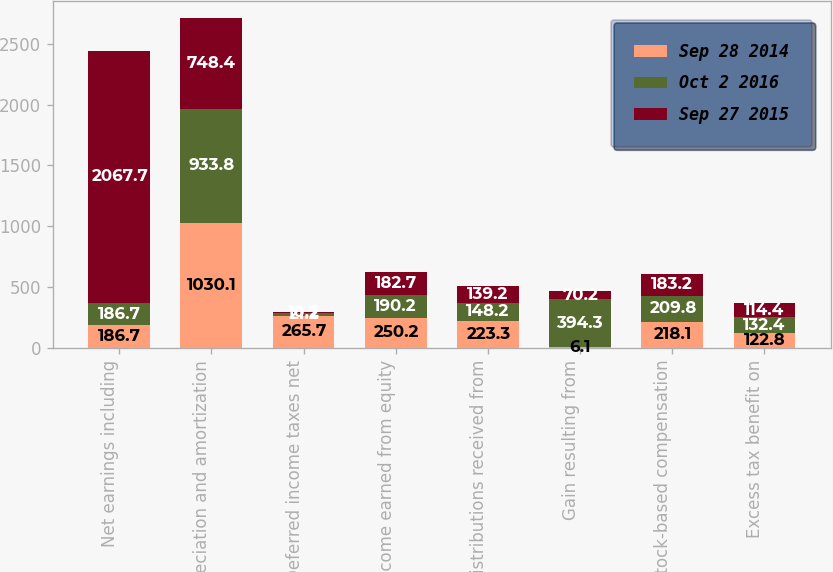<chart> <loc_0><loc_0><loc_500><loc_500><stacked_bar_chart><ecel><fcel>Net earnings including<fcel>Depreciation and amortization<fcel>Deferred income taxes net<fcel>Income earned from equity<fcel>Distributions received from<fcel>Gain resulting from<fcel>Stock-based compensation<fcel>Excess tax benefit on<nl><fcel>Sep 28 2014<fcel>186.7<fcel>1030.1<fcel>265.7<fcel>250.2<fcel>223.3<fcel>6.1<fcel>218.1<fcel>122.8<nl><fcel>Oct 2 2016<fcel>186.7<fcel>933.8<fcel>21.2<fcel>190.2<fcel>148.2<fcel>394.3<fcel>209.8<fcel>132.4<nl><fcel>Sep 27 2015<fcel>2067.7<fcel>748.4<fcel>10.2<fcel>182.7<fcel>139.2<fcel>70.2<fcel>183.2<fcel>114.4<nl></chart> 